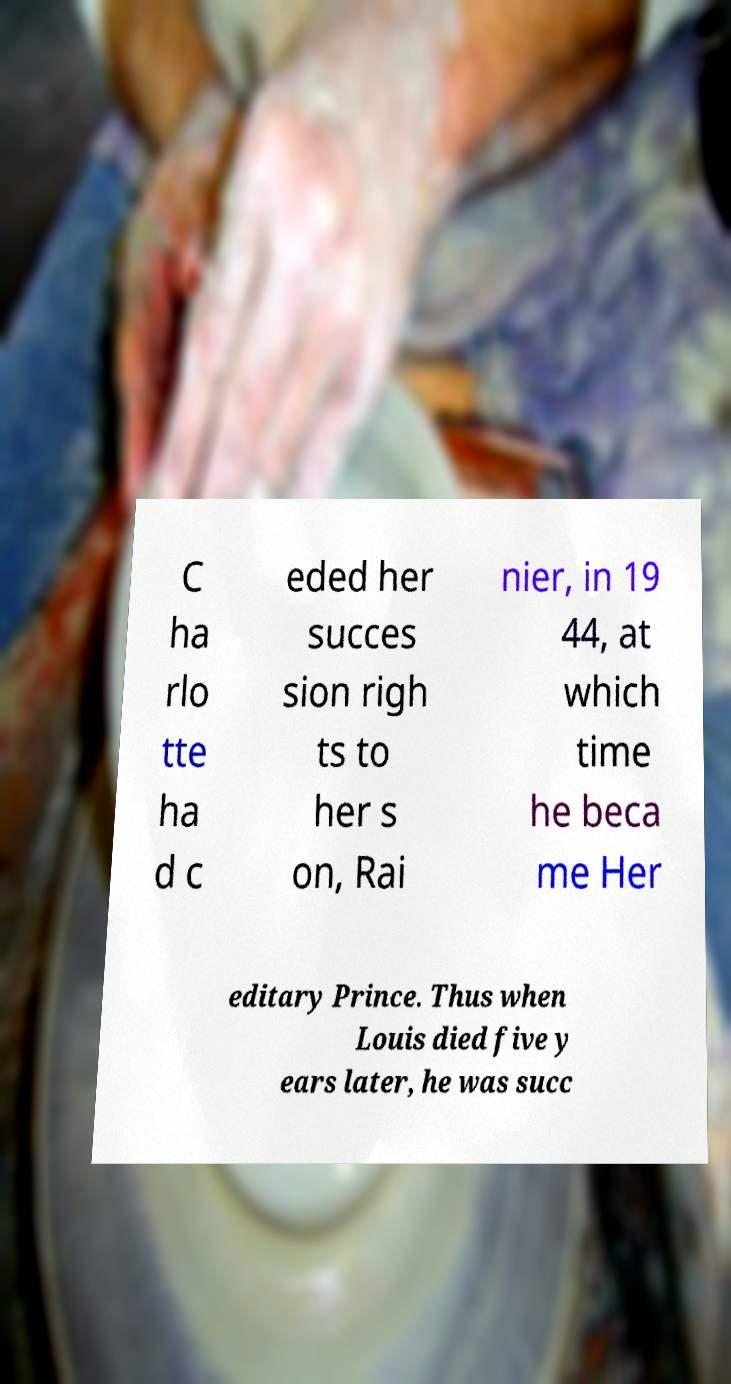Could you extract and type out the text from this image? C ha rlo tte ha d c eded her succes sion righ ts to her s on, Rai nier, in 19 44, at which time he beca me Her editary Prince. Thus when Louis died five y ears later, he was succ 